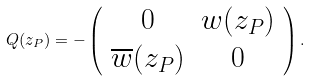<formula> <loc_0><loc_0><loc_500><loc_500>Q ( z _ { P } ) = - \left ( \begin{array} { c c } 0 & w ( z _ { P } ) \\ \overline { w } ( z _ { P } ) & 0 \\ \end{array} \right ) .</formula> 